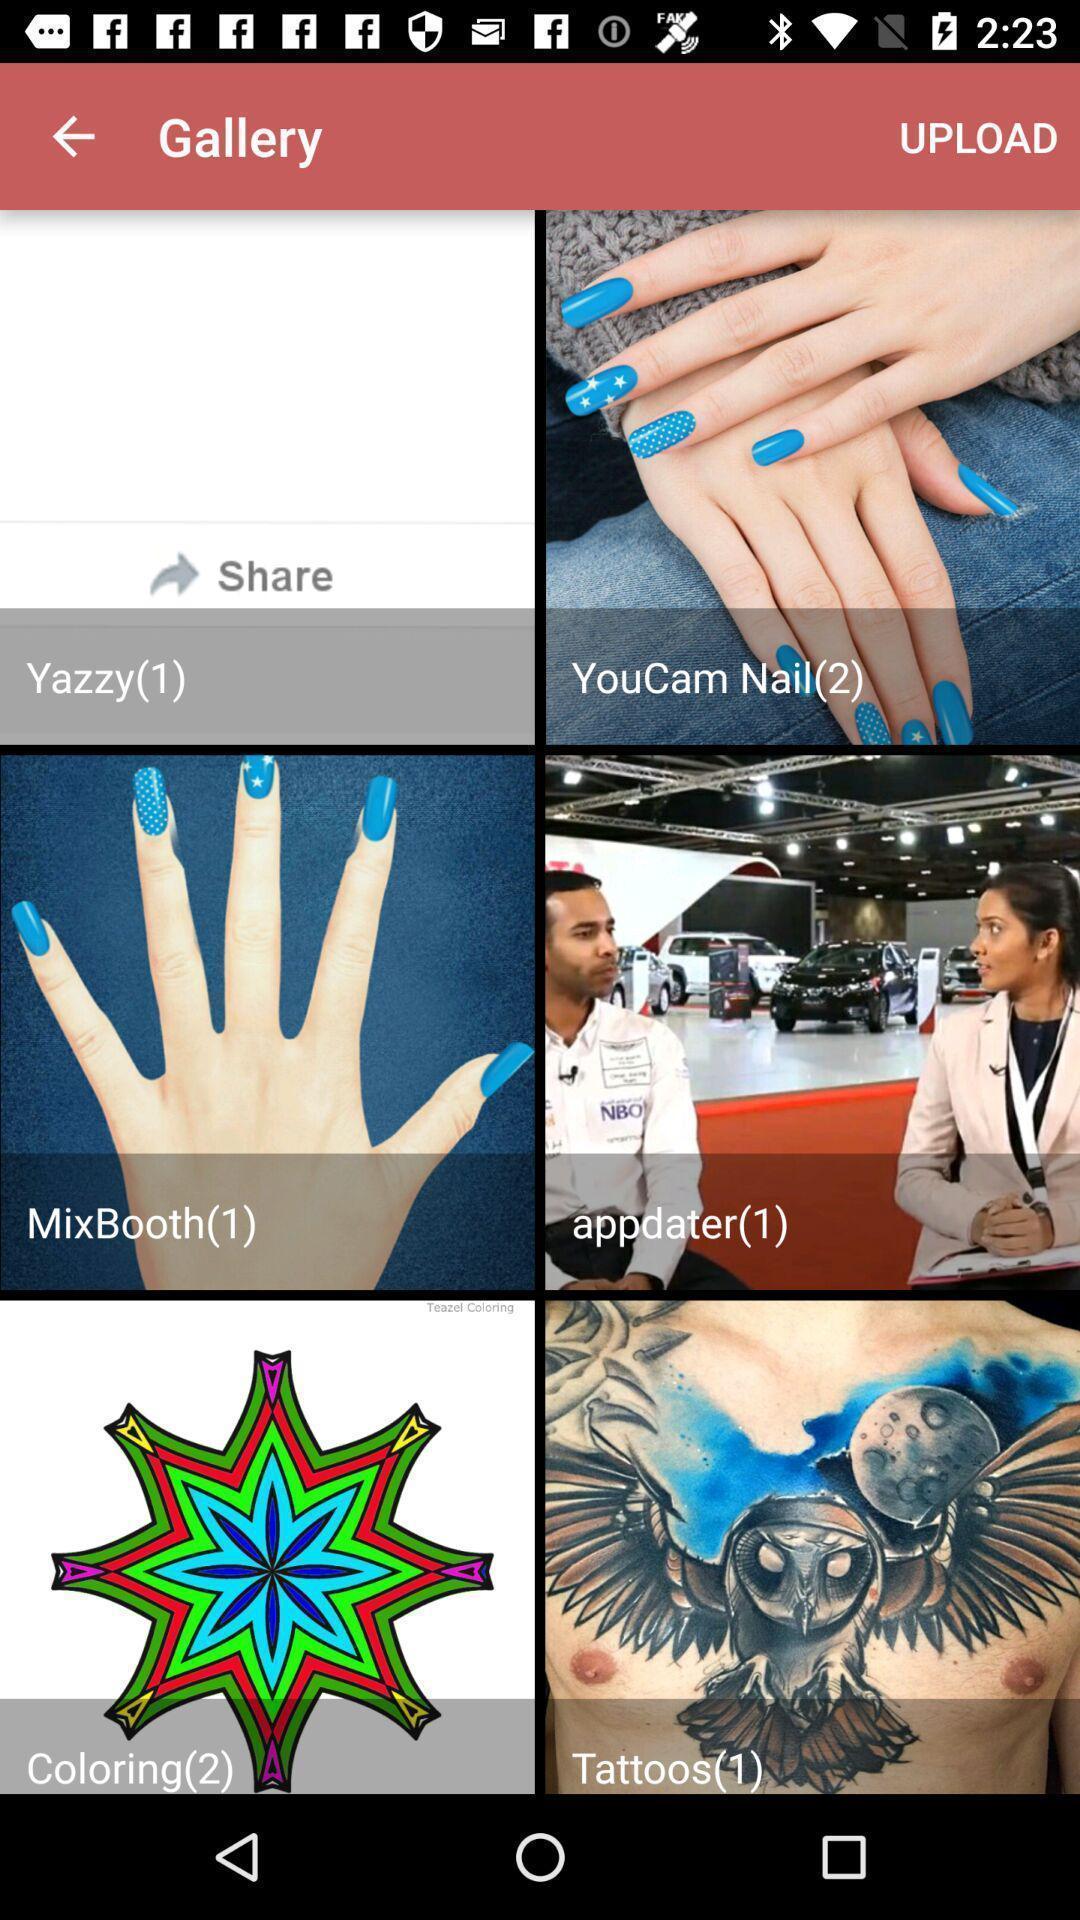Explain what's happening in this screen capture. Page showing various images in gallery. 